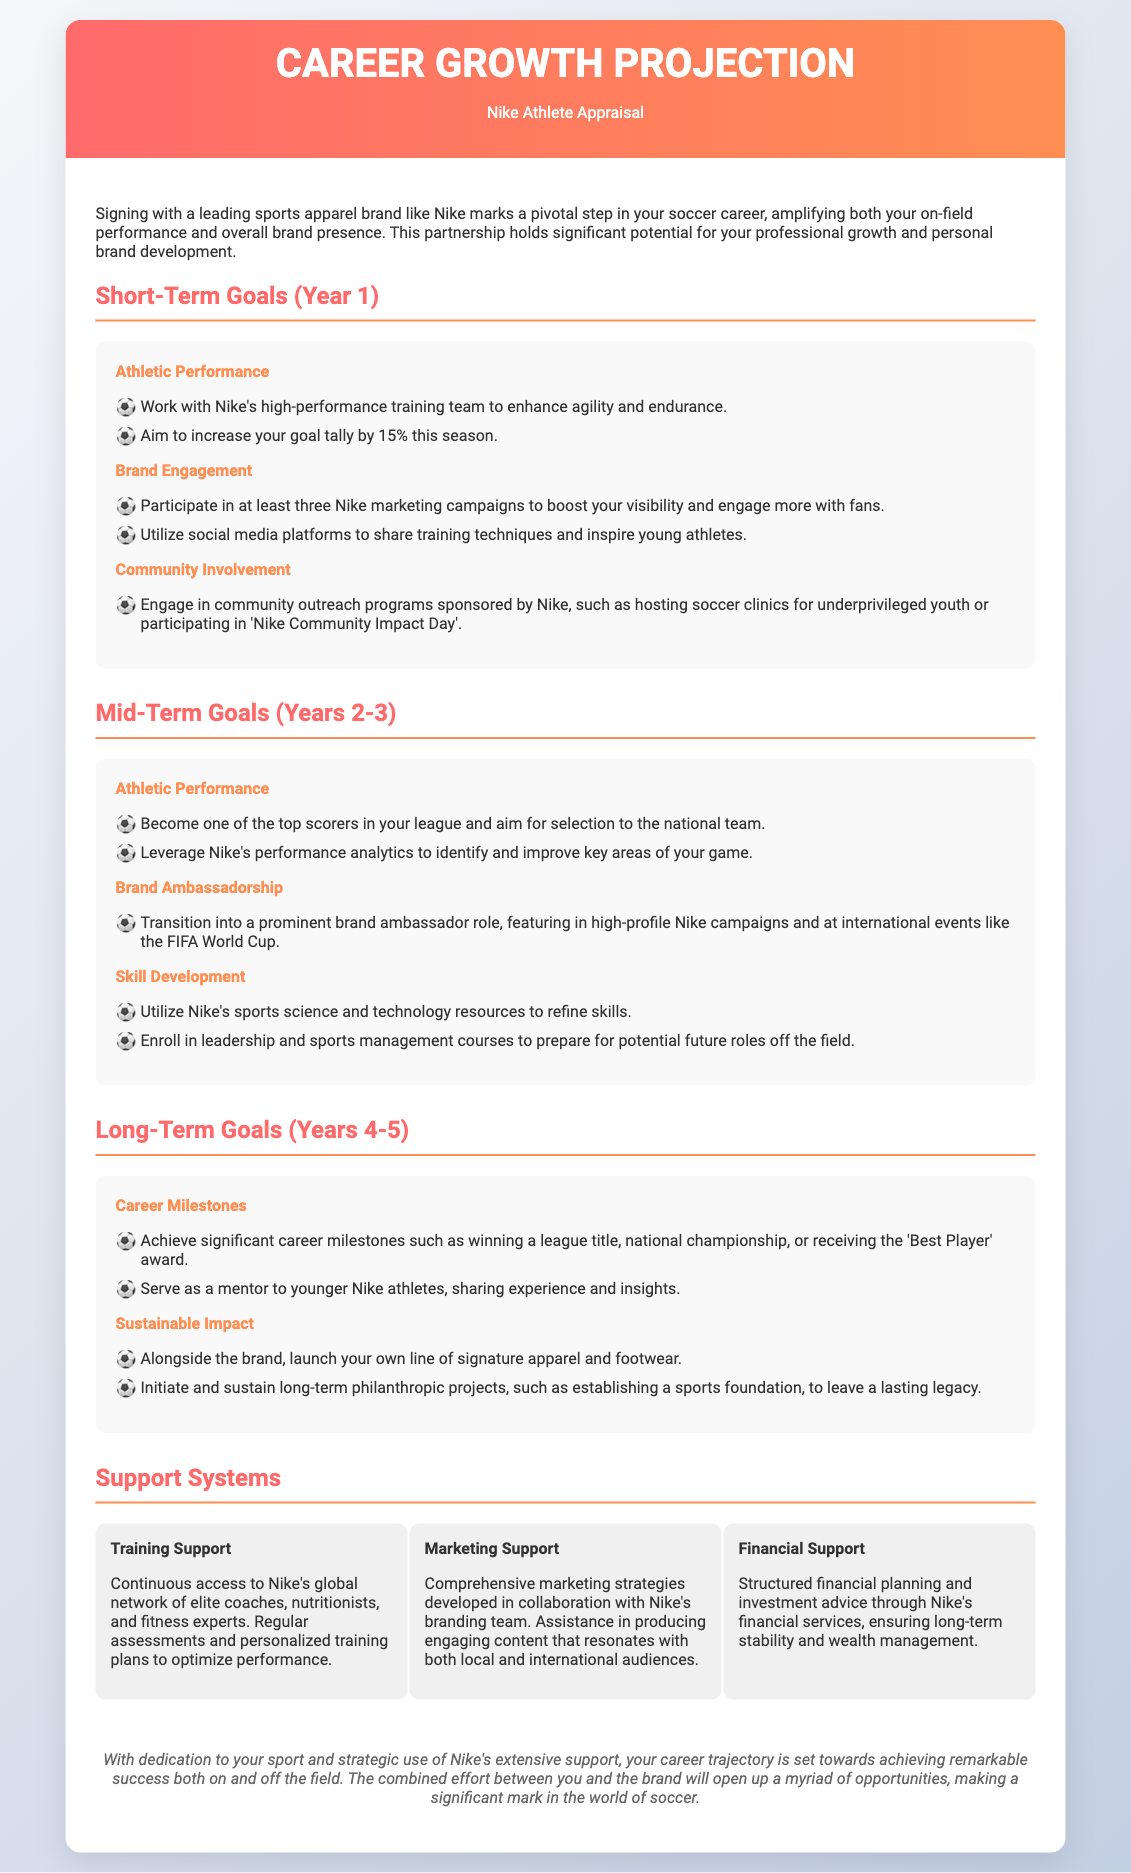What are the short-term goals for athletic performance? The short-term goals for athletic performance include working with Nike's high-performance training team and aiming to increase the goal tally by 15%.
Answer: Work with Nike's high-performance training team; increase goal tally by 15% What is the focus of the mid-term goals regarding brand ambassadorship? The mid-term goals for brand ambassadorship involve transitioning into a prominent brand ambassador role.
Answer: Transition into a prominent brand ambassador role What is one long-term career milestone mentioned? The document lists significant career milestones such as winning a league title.
Answer: Winning a league title How many Nike marketing campaigns does the document suggest participating in during the first year? The document specifies participation in at least three Nike marketing campaigns.
Answer: Three What type of training support is provided by Nike? Continuous access to Nike's global network of elite coaches, nutritionists, and fitness experts is specified as training support.
Answer: Continuous access to Nike's global network of elite coaches How many years does the mid-term goals span? The mid-term goals outlined in the document are for a period of 2 to 3 years.
Answer: 2-3 years What community involvement is encouraged in the first year? The document encourages engaging in community outreach programs like hosting soccer clinics for underprivileged youth.
Answer: Hosting soccer clinics for underprivileged youth What is a long-term philanthropic project mentioned? Establishing a sports foundation is mentioned as a long-term philanthropic project.
Answer: Establishing a sports foundation What resource does Nike provide for athlete performance tracking? Nike provides performance analytics to identify and improve key areas of the athlete's game.
Answer: Performance analytics 